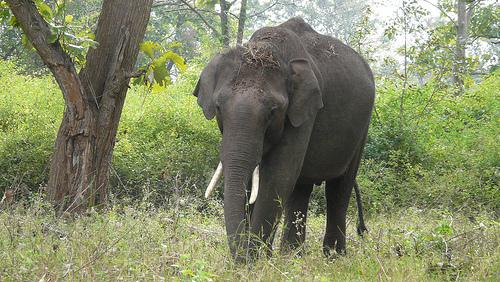Question: how many elephants?
Choices:
A. 2.
B. 3.
C. 1.
D. 4.
Answer with the letter. Answer: C Question: what does the elephant have?
Choices:
A. Tusks.
B. Trunk.
C. Hay.
D. Riders.
Answer with the letter. Answer: A 